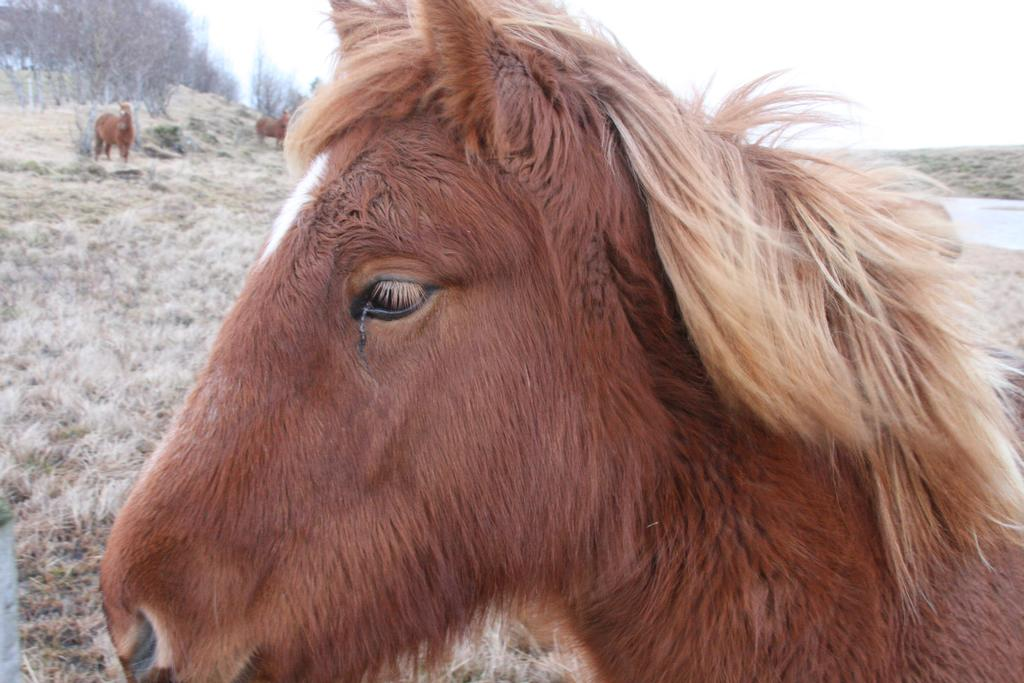What is the main subject in the front of the image? There is an animal in the front of the image. What can be seen on the ground in the background? There is dry grass on the ground in the background. What are the animals in the background doing? There are animals standing in the background. What type of natural features can be seen in the background? There are trees and water visible in the background. How many babies are sitting on the rock in the image? There is no rock or babies present in the image. 